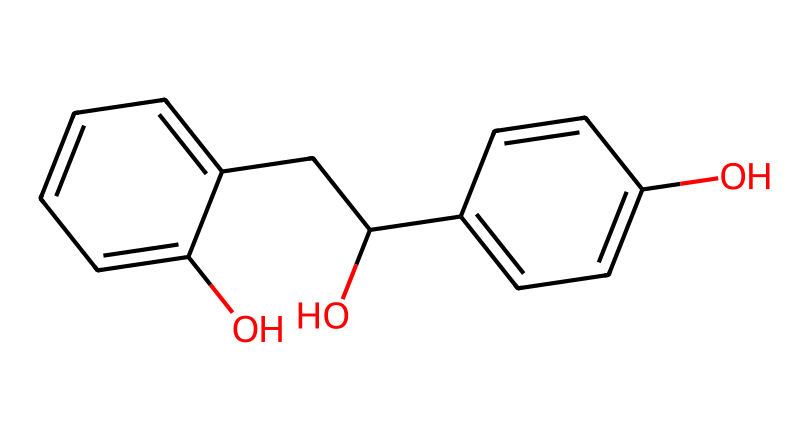What is the total number of carbon atoms in the structure? By counting the carbon atoms represented in the SMILES string and visualizing the structure, we observe that there are a total of 15 carbon atoms connected in various arrangements.
Answer: 15 How many hydroxyl (–OH) groups are present in this molecule? The SMILES notation contains two instances of "C(O)", indicating that there are two hydroxyl groups in the structure; this can be confirmed by examining its visual structure.
Answer: 2 What type of chemical bond connects the carbon atoms in this structure? The carbon atoms are connected by single bonds and double bonds, which can be distinguished when interpreting the structure and relationships indicated by the SMILES syntax.
Answer: single and double bonds How many rings are present in the molecular structure? Analyzing the cyclic portions of the SMILES, we see that there are two distinct rings, indicating the presence of aromatic characteristics typical in phenolic compounds.
Answer: 2 Which type of chemical predominates in this compound, phenol or aldehyde? By identifying the functional groups in the structure via the SMILES representation, we find that the phenolic groups are more prominent, as evidenced by the presence of multiple hydroxyl groups and aromatic rings compared to a single aldehyde group.
Answer: phenol What is the likelihood of this compound being soluble in water? Given the presence of two hydroxyl groups in the structure that can form hydrogen bonds with water, it is reasonable to deduce that this compound will have good water solubility.
Answer: high Does this structure exhibit any chiral centers? Upon examining the carbon atoms for tetravalency and unique attachments, it is clear that the stereogenic configurations required for chirality are absent, indicating the lack of chiral centers.
Answer: none 